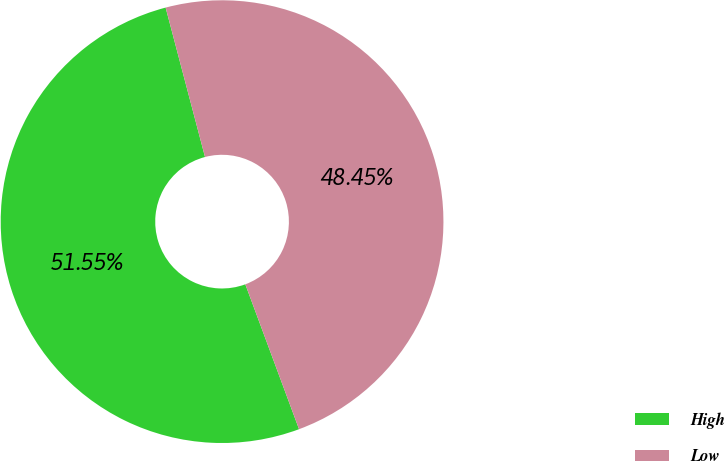Convert chart. <chart><loc_0><loc_0><loc_500><loc_500><pie_chart><fcel>High<fcel>Low<nl><fcel>51.55%<fcel>48.45%<nl></chart> 